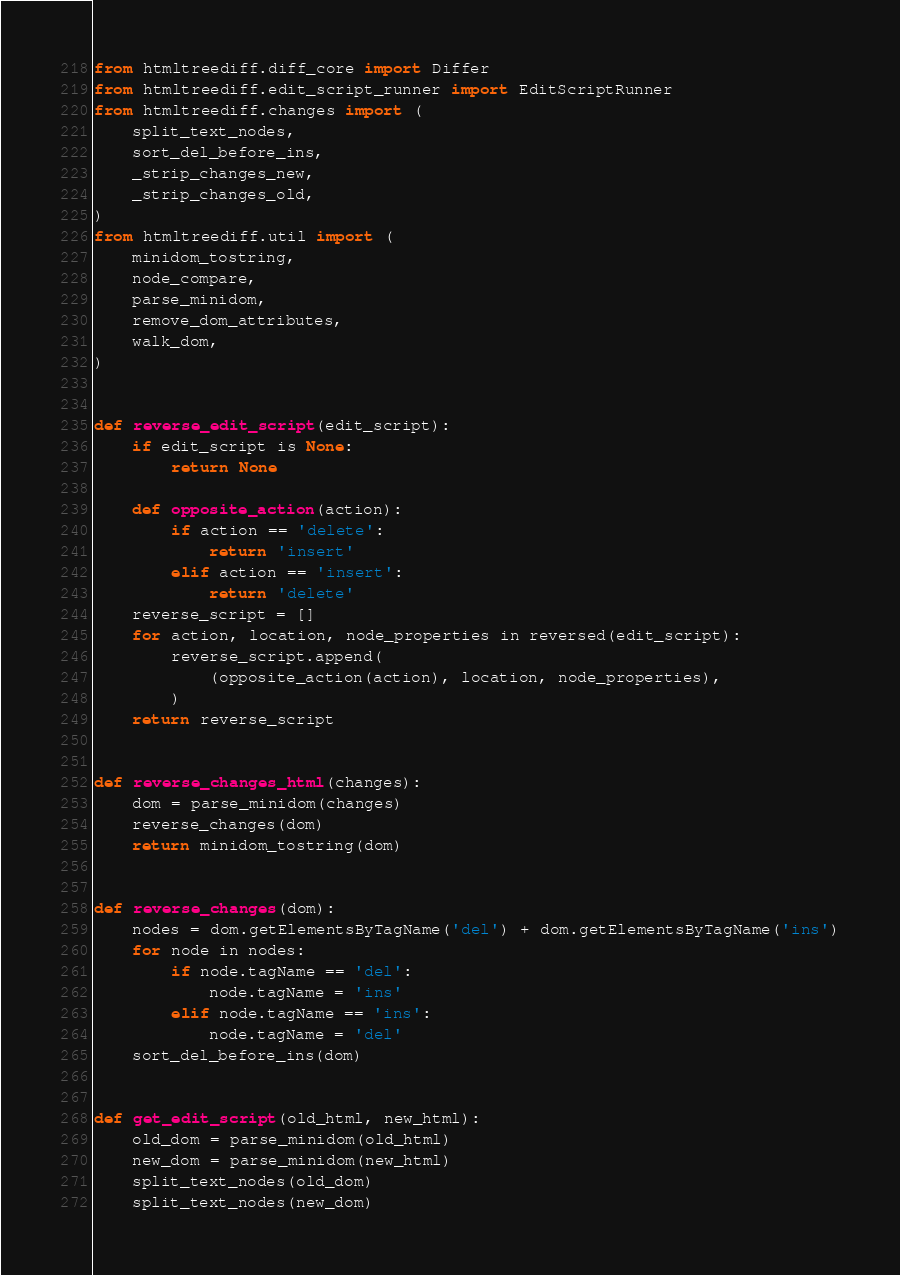Convert code to text. <code><loc_0><loc_0><loc_500><loc_500><_Python_>from htmltreediff.diff_core import Differ
from htmltreediff.edit_script_runner import EditScriptRunner
from htmltreediff.changes import (
    split_text_nodes,
    sort_del_before_ins,
    _strip_changes_new,
    _strip_changes_old,
)
from htmltreediff.util import (
    minidom_tostring,
    node_compare,
    parse_minidom,
    remove_dom_attributes,
    walk_dom,
)


def reverse_edit_script(edit_script):
    if edit_script is None:
        return None

    def opposite_action(action):
        if action == 'delete':
            return 'insert'
        elif action == 'insert':
            return 'delete'
    reverse_script = []
    for action, location, node_properties in reversed(edit_script):
        reverse_script.append(
            (opposite_action(action), location, node_properties),
        )
    return reverse_script


def reverse_changes_html(changes):
    dom = parse_minidom(changes)
    reverse_changes(dom)
    return minidom_tostring(dom)


def reverse_changes(dom):
    nodes = dom.getElementsByTagName('del') + dom.getElementsByTagName('ins')
    for node in nodes:
        if node.tagName == 'del':
            node.tagName = 'ins'
        elif node.tagName == 'ins':
            node.tagName = 'del'
    sort_del_before_ins(dom)


def get_edit_script(old_html, new_html):
    old_dom = parse_minidom(old_html)
    new_dom = parse_minidom(new_html)
    split_text_nodes(old_dom)
    split_text_nodes(new_dom)</code> 